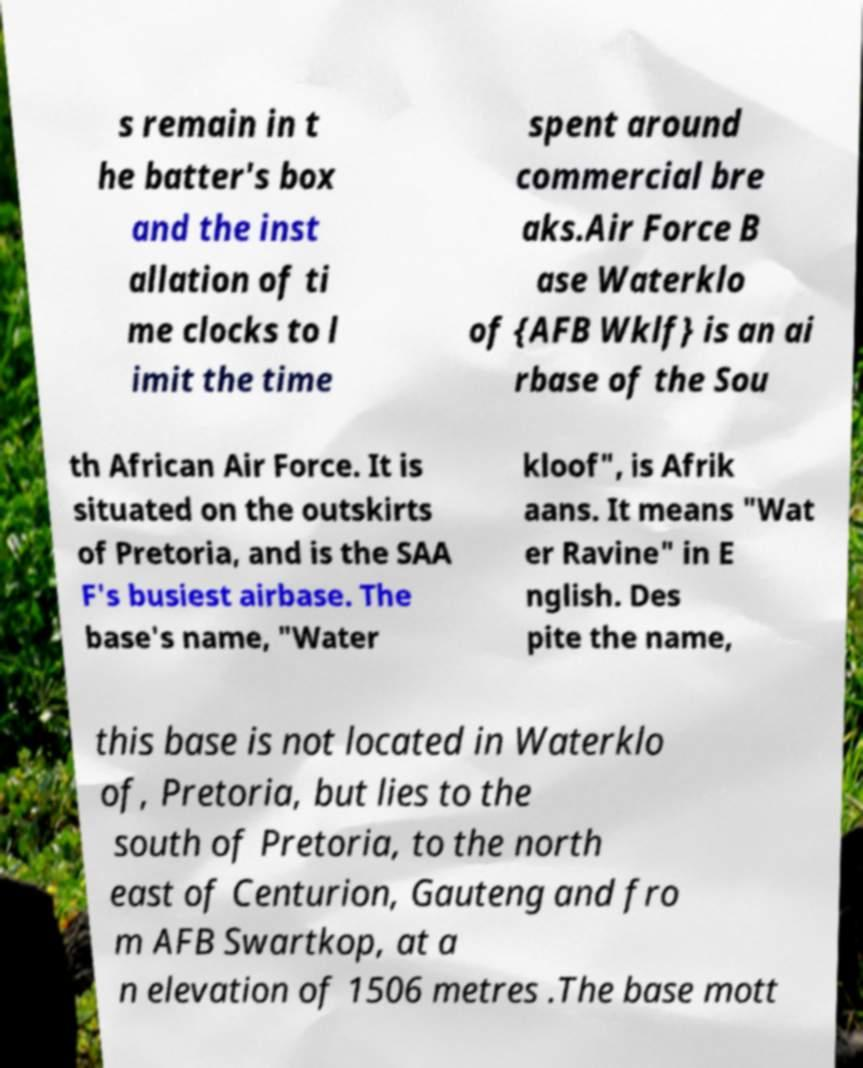Can you read and provide the text displayed in the image?This photo seems to have some interesting text. Can you extract and type it out for me? s remain in t he batter's box and the inst allation of ti me clocks to l imit the time spent around commercial bre aks.Air Force B ase Waterklo of {AFB Wklf} is an ai rbase of the Sou th African Air Force. It is situated on the outskirts of Pretoria, and is the SAA F's busiest airbase. The base's name, "Water kloof", is Afrik aans. It means "Wat er Ravine" in E nglish. Des pite the name, this base is not located in Waterklo of, Pretoria, but lies to the south of Pretoria, to the north east of Centurion, Gauteng and fro m AFB Swartkop, at a n elevation of 1506 metres .The base mott 